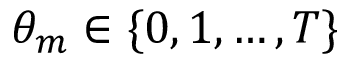Convert formula to latex. <formula><loc_0><loc_0><loc_500><loc_500>\theta _ { m } \in \{ 0 , 1 , \dots , T \}</formula> 